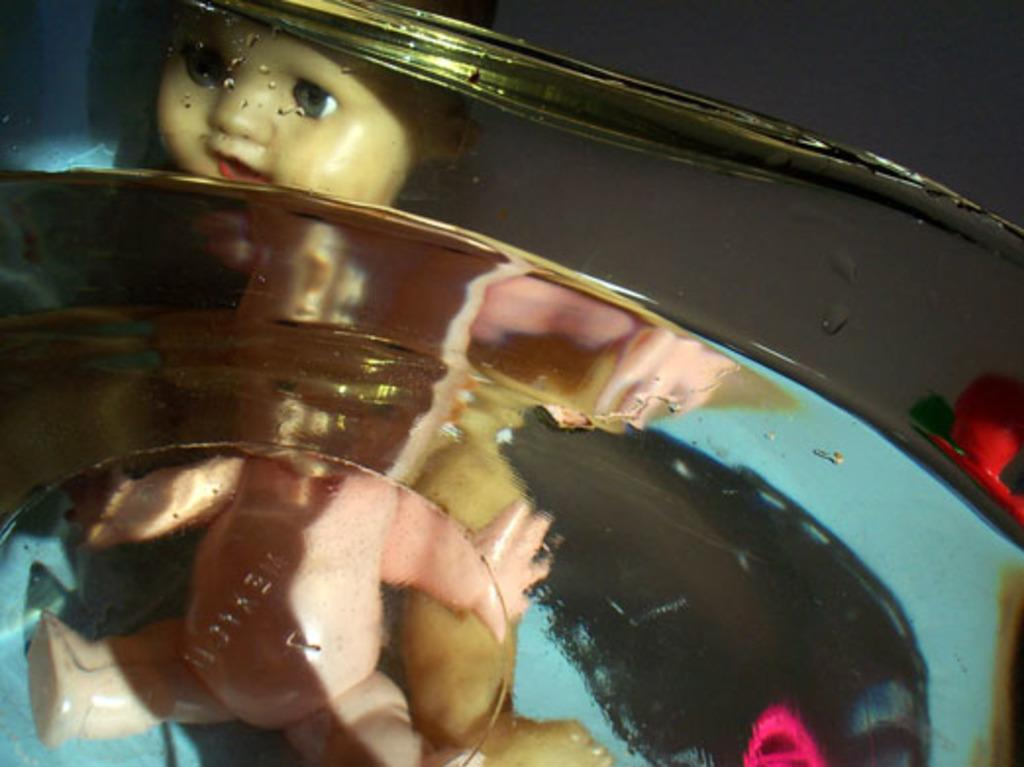What is the main subject of the image? There is a doll in the image. Can you describe the doll's location or surroundings? The doll is behind a glass material. What type of robin can be seen interacting with the doll behind the glass material in the image? There is no robin present in the image, and therefore no such interaction can be observed. 